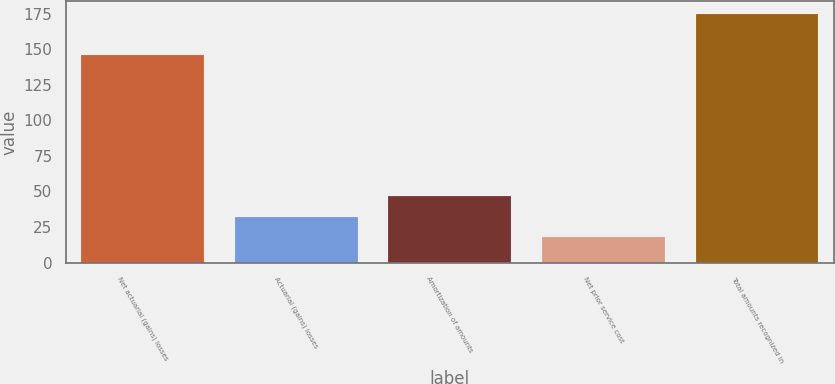Convert chart. <chart><loc_0><loc_0><loc_500><loc_500><bar_chart><fcel>Net actuarial (gains) losses<fcel>Actuarial (gains) losses<fcel>Amortization of amounts<fcel>Net prior service cost<fcel>Total amounts recognized in<nl><fcel>145.7<fcel>32.36<fcel>47.04<fcel>17.68<fcel>175.06<nl></chart> 